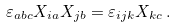<formula> <loc_0><loc_0><loc_500><loc_500>\varepsilon _ { a b c } X _ { i a } X _ { j b } = \varepsilon _ { i j k } X _ { k c } \, .</formula> 